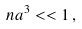<formula> <loc_0><loc_0><loc_500><loc_500>n a ^ { 3 } < < 1 \, ,</formula> 